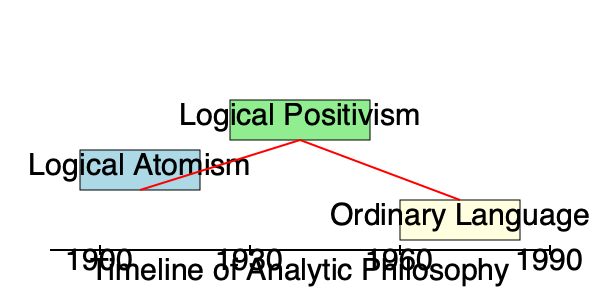According to Conant's perspective on the development of analytic philosophy, which phase represented by the red line in the timeline marks a significant shift that Conant critically examines in his work on the history of analytic philosophy? To answer this question, we need to consider Conant's views on the development of analytic philosophy:

1. The timeline shows three main phases of analytic philosophy: Logical Atomism, Logical Positivism, and Ordinary Language Philosophy.

2. The red line connects these phases, indicating transitions between them.

3. Conant's work often focuses on the transition from Logical Positivism to post-positivist philosophy, particularly the shift towards Ordinary Language Philosophy.

4. This transition, represented by the second segment of the red line (from Logical Positivism to Ordinary Language Philosophy), is crucial in Conant's analysis.

5. Conant critically examines this shift, arguing that it represents a fundamental change in how philosophers approached language and meaning.

6. He challenges the standard narrative that sees this transition as a clean break, instead emphasizing continuities and shared concerns across these periods.

7. Conant's work highlights how this shift involved a reevaluation of the role of ordinary language in philosophical analysis, moving away from the more formalized approaches of Logical Positivism.

Therefore, the significant shift that Conant critically examines is the transition from Logical Positivism to Ordinary Language Philosophy, represented by the second segment of the red line in the timeline.
Answer: The transition from Logical Positivism to Ordinary Language Philosophy 